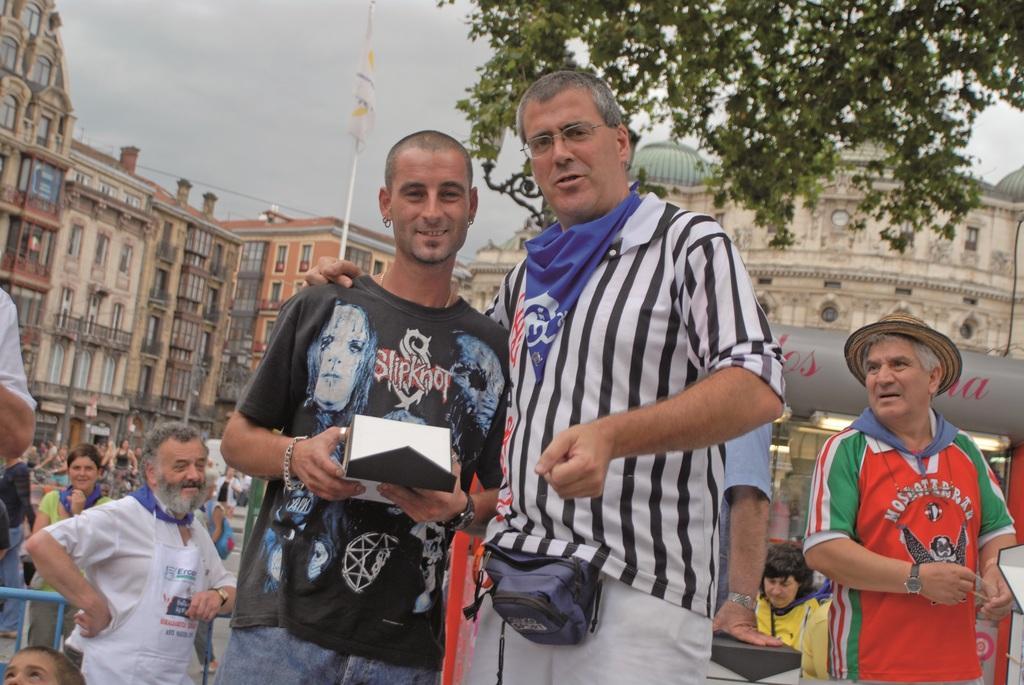How would you summarize this image in a sentence or two? In the background we can see the sky. In this picture we can see the buildings. At the top we can see the domes and a board. We can see a flag and a white pole. We can see people and a man is standing near to the fence. We can see two men standing and a man wearing black t-shirt is holding an object in his hands. On the right side of the picture we can see a tree. 